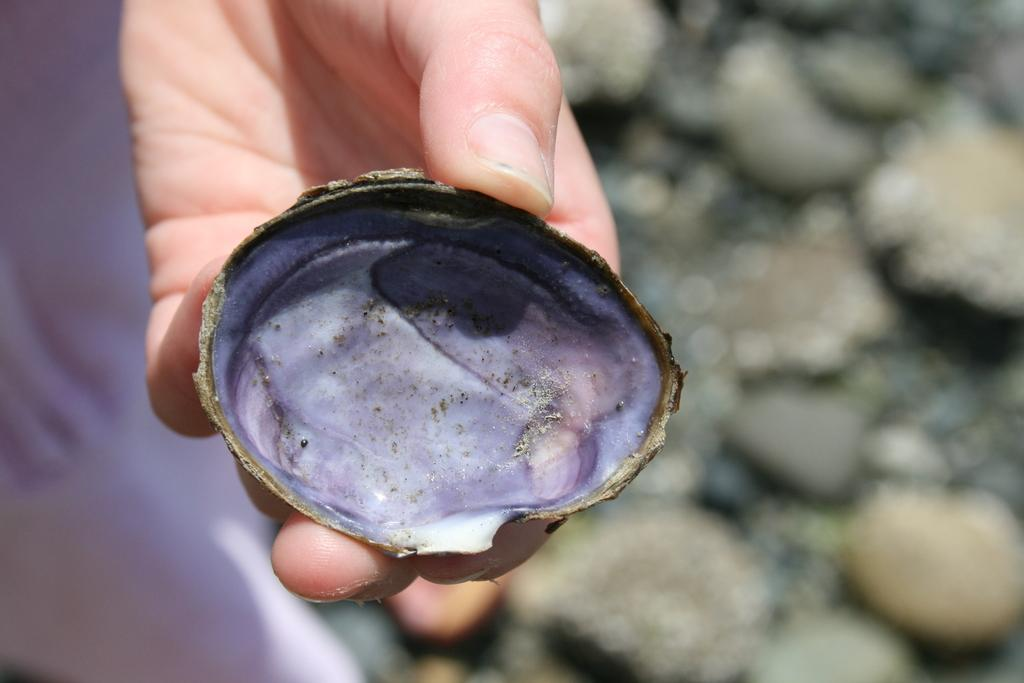Who is present in the image? There is a man in the image. What is the man holding in the image? The man is holding a shell. What can be seen at the bottom of the image? There are stones at the bottom of the image. How would you describe the clarity of the image? The image is blurry. What type of van is parked next to the man in the image? There is no van present in the image; it only features a man holding a shell and stones at the bottom. 